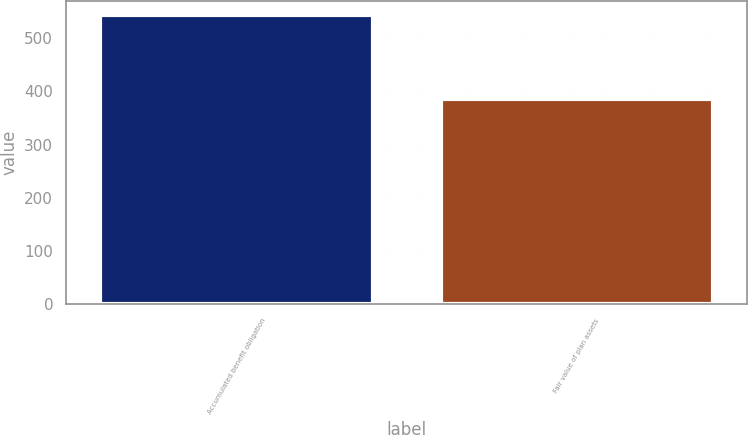<chart> <loc_0><loc_0><loc_500><loc_500><bar_chart><fcel>Accumulated benefit obligation<fcel>Fair value of plan assets<nl><fcel>543.5<fcel>384.9<nl></chart> 